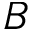Convert formula to latex. <formula><loc_0><loc_0><loc_500><loc_500>B</formula> 